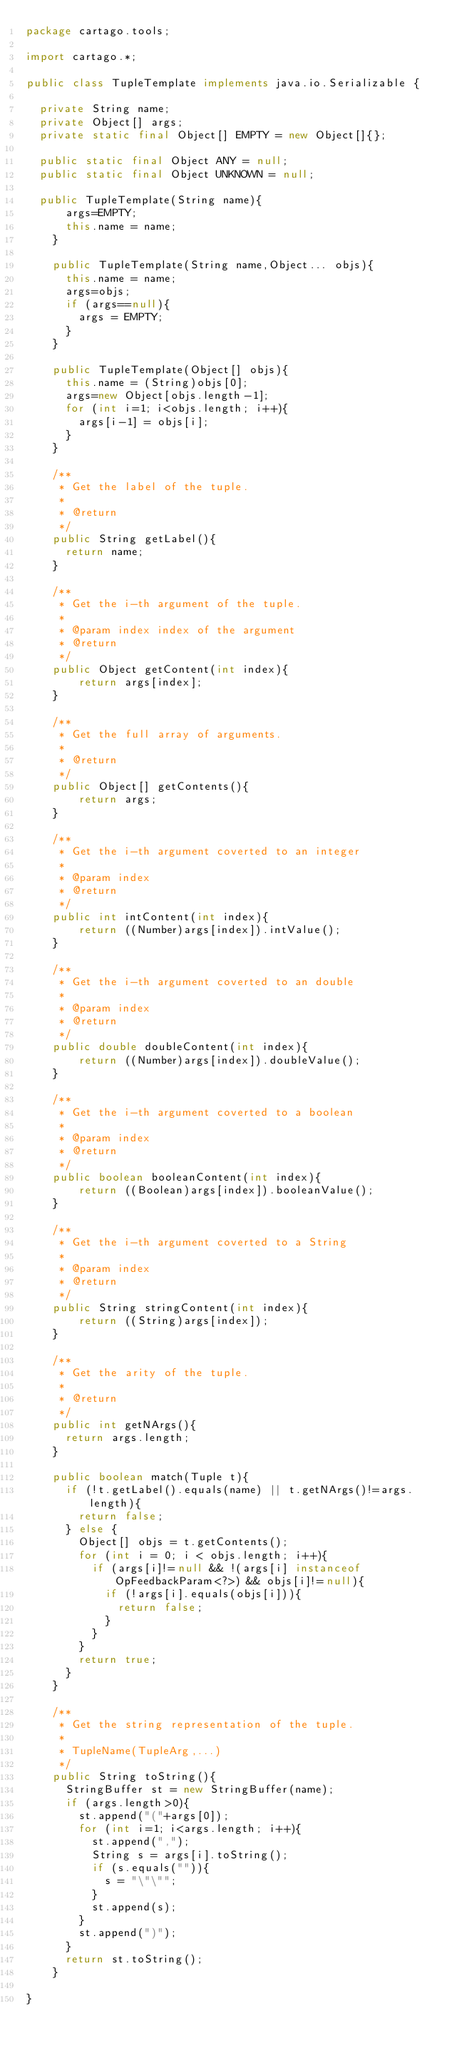<code> <loc_0><loc_0><loc_500><loc_500><_Java_>package cartago.tools;

import cartago.*;

public class TupleTemplate implements java.io.Serializable {

	private String name;
	private Object[] args;
	private static final Object[] EMPTY = new Object[]{};

	public static final Object ANY = null;
	public static final Object UNKNOWN = null;
    	
	public TupleTemplate(String name){
    	args=EMPTY;
    	this.name = name;
    }

    public TupleTemplate(String name,Object... objs){
    	this.name = name;
    	args=objs;
    	if (args==null){
    		args = EMPTY;
    	}
    }

    public TupleTemplate(Object[] objs){
    	this.name = (String)objs[0];
    	args=new Object[objs.length-1];
    	for (int i=1; i<objs.length; i++){
    		args[i-1] = objs[i];
    	}
    }
    
    /**
     * Get the label of the tuple.
     * 
     * @return
     */
    public String getLabel(){
    	return name;
    }

    /**
     * Get the i-th argument of the tuple.
     * 
     * @param index index of the argument
     * @return
     */
    public Object getContent(int index){
        return args[index];
    }

    /**
     * Get the full array of arguments.
     * 
     * @return
     */
    public Object[] getContents(){
        return args;
    }

    /**
     * Get the i-th argument coverted to an integer
     * 
     * @param index
     * @return
     */
    public int intContent(int index){
        return ((Number)args[index]).intValue();
    }

    /**
     * Get the i-th argument coverted to an double
     * 
     * @param index
     * @return
     */
    public double doubleContent(int index){
        return ((Number)args[index]).doubleValue();
    }
    
    /**
     * Get the i-th argument coverted to a boolean
     * 
     * @param index
     * @return
     */
    public boolean booleanContent(int index){
        return ((Boolean)args[index]).booleanValue();
    }

    /**
     * Get the i-th argument coverted to a String
     * 
     * @param index
     * @return
     */
    public String stringContent(int index){
        return ((String)args[index]);
    }

    /**
     * Get the arity of the tuple.
     * 
     * @return
     */
    public int getNArgs(){
    	return args.length;
    }
    
    public boolean match(Tuple t){
    	if (!t.getLabel().equals(name) || t.getNArgs()!=args.length){
    		return false;
    	} else {
    		Object[] objs = t.getContents();
    		for (int i = 0; i < objs.length; i++){
    			if (args[i]!=null && !(args[i] instanceof OpFeedbackParam<?>) && objs[i]!=null){
    				if (!args[i].equals(objs[i])){
    					return false;
    				}
    			}
    		}
    		return true;
    	}
    }
    
    /**
     * Get the string representation of the tuple.
     * 
     * TupleName(TupleArg,...)
     */
    public String toString(){
    	StringBuffer st = new StringBuffer(name);
    	if (args.length>0){
    		st.append("("+args[0]);
    		for (int i=1; i<args.length; i++){
    			st.append(",");
    			String s = args[i].toString();
    			if (s.equals("")){
    				s = "\"\"";
    			}
    			st.append(s);	
	    	}
    		st.append(")");
    	}
    	return st.toString();
    }

}
</code> 